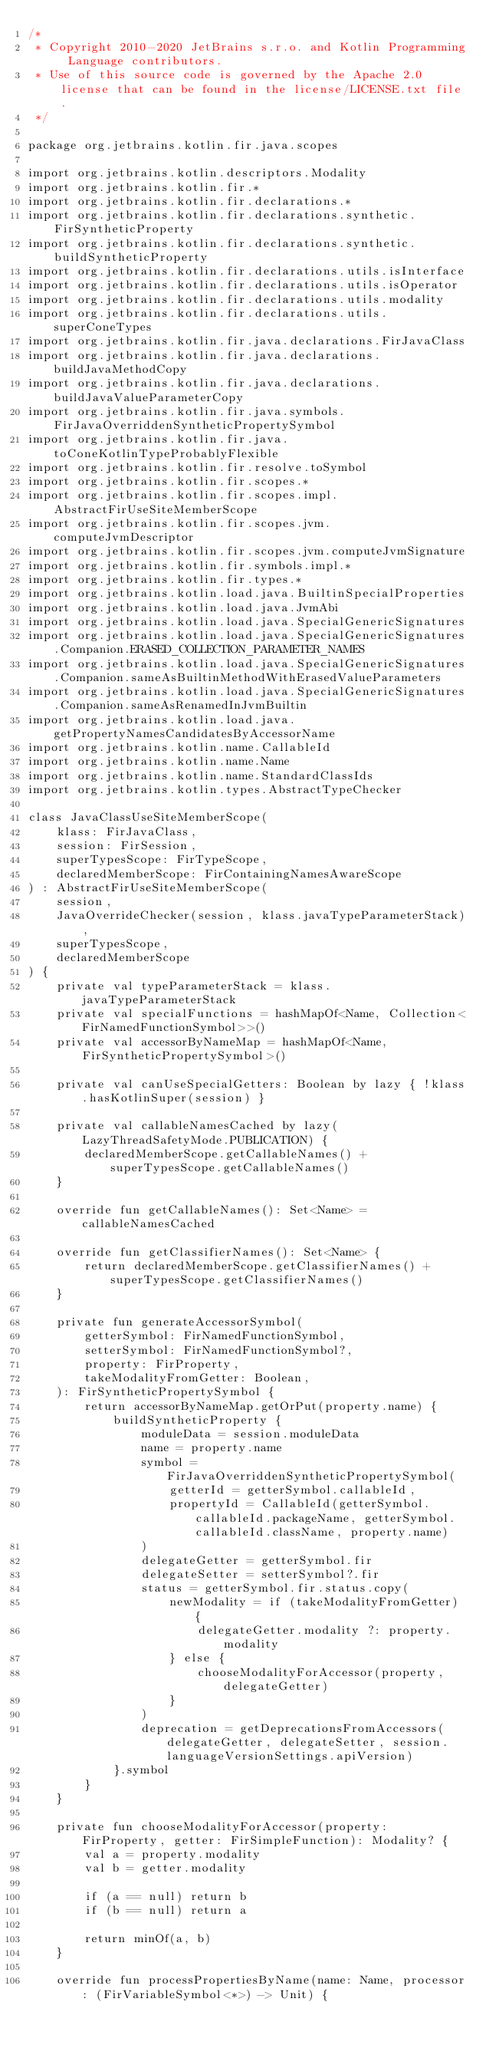Convert code to text. <code><loc_0><loc_0><loc_500><loc_500><_Kotlin_>/*
 * Copyright 2010-2020 JetBrains s.r.o. and Kotlin Programming Language contributors.
 * Use of this source code is governed by the Apache 2.0 license that can be found in the license/LICENSE.txt file.
 */

package org.jetbrains.kotlin.fir.java.scopes

import org.jetbrains.kotlin.descriptors.Modality
import org.jetbrains.kotlin.fir.*
import org.jetbrains.kotlin.fir.declarations.*
import org.jetbrains.kotlin.fir.declarations.synthetic.FirSyntheticProperty
import org.jetbrains.kotlin.fir.declarations.synthetic.buildSyntheticProperty
import org.jetbrains.kotlin.fir.declarations.utils.isInterface
import org.jetbrains.kotlin.fir.declarations.utils.isOperator
import org.jetbrains.kotlin.fir.declarations.utils.modality
import org.jetbrains.kotlin.fir.declarations.utils.superConeTypes
import org.jetbrains.kotlin.fir.java.declarations.FirJavaClass
import org.jetbrains.kotlin.fir.java.declarations.buildJavaMethodCopy
import org.jetbrains.kotlin.fir.java.declarations.buildJavaValueParameterCopy
import org.jetbrains.kotlin.fir.java.symbols.FirJavaOverriddenSyntheticPropertySymbol
import org.jetbrains.kotlin.fir.java.toConeKotlinTypeProbablyFlexible
import org.jetbrains.kotlin.fir.resolve.toSymbol
import org.jetbrains.kotlin.fir.scopes.*
import org.jetbrains.kotlin.fir.scopes.impl.AbstractFirUseSiteMemberScope
import org.jetbrains.kotlin.fir.scopes.jvm.computeJvmDescriptor
import org.jetbrains.kotlin.fir.scopes.jvm.computeJvmSignature
import org.jetbrains.kotlin.fir.symbols.impl.*
import org.jetbrains.kotlin.fir.types.*
import org.jetbrains.kotlin.load.java.BuiltinSpecialProperties
import org.jetbrains.kotlin.load.java.JvmAbi
import org.jetbrains.kotlin.load.java.SpecialGenericSignatures
import org.jetbrains.kotlin.load.java.SpecialGenericSignatures.Companion.ERASED_COLLECTION_PARAMETER_NAMES
import org.jetbrains.kotlin.load.java.SpecialGenericSignatures.Companion.sameAsBuiltinMethodWithErasedValueParameters
import org.jetbrains.kotlin.load.java.SpecialGenericSignatures.Companion.sameAsRenamedInJvmBuiltin
import org.jetbrains.kotlin.load.java.getPropertyNamesCandidatesByAccessorName
import org.jetbrains.kotlin.name.CallableId
import org.jetbrains.kotlin.name.Name
import org.jetbrains.kotlin.name.StandardClassIds
import org.jetbrains.kotlin.types.AbstractTypeChecker

class JavaClassUseSiteMemberScope(
    klass: FirJavaClass,
    session: FirSession,
    superTypesScope: FirTypeScope,
    declaredMemberScope: FirContainingNamesAwareScope
) : AbstractFirUseSiteMemberScope(
    session,
    JavaOverrideChecker(session, klass.javaTypeParameterStack),
    superTypesScope,
    declaredMemberScope
) {
    private val typeParameterStack = klass.javaTypeParameterStack
    private val specialFunctions = hashMapOf<Name, Collection<FirNamedFunctionSymbol>>()
    private val accessorByNameMap = hashMapOf<Name, FirSyntheticPropertySymbol>()
    
    private val canUseSpecialGetters: Boolean by lazy { !klass.hasKotlinSuper(session) }

    private val callableNamesCached by lazy(LazyThreadSafetyMode.PUBLICATION) {
        declaredMemberScope.getCallableNames() + superTypesScope.getCallableNames()
    }

    override fun getCallableNames(): Set<Name> = callableNamesCached

    override fun getClassifierNames(): Set<Name> {
        return declaredMemberScope.getClassifierNames() + superTypesScope.getClassifierNames()
    }

    private fun generateAccessorSymbol(
        getterSymbol: FirNamedFunctionSymbol,
        setterSymbol: FirNamedFunctionSymbol?,
        property: FirProperty,
        takeModalityFromGetter: Boolean,
    ): FirSyntheticPropertySymbol {
        return accessorByNameMap.getOrPut(property.name) {
            buildSyntheticProperty {
                moduleData = session.moduleData
                name = property.name
                symbol = FirJavaOverriddenSyntheticPropertySymbol(
                    getterId = getterSymbol.callableId,
                    propertyId = CallableId(getterSymbol.callableId.packageName, getterSymbol.callableId.className, property.name)
                )
                delegateGetter = getterSymbol.fir
                delegateSetter = setterSymbol?.fir
                status = getterSymbol.fir.status.copy(
                    newModality = if (takeModalityFromGetter) {
                        delegateGetter.modality ?: property.modality
                    } else {
                        chooseModalityForAccessor(property, delegateGetter)
                    }
                )
                deprecation = getDeprecationsFromAccessors(delegateGetter, delegateSetter, session.languageVersionSettings.apiVersion)
            }.symbol
        }
    }

    private fun chooseModalityForAccessor(property: FirProperty, getter: FirSimpleFunction): Modality? {
        val a = property.modality
        val b = getter.modality

        if (a == null) return b
        if (b == null) return a

        return minOf(a, b)
    }

    override fun processPropertiesByName(name: Name, processor: (FirVariableSymbol<*>) -> Unit) {</code> 